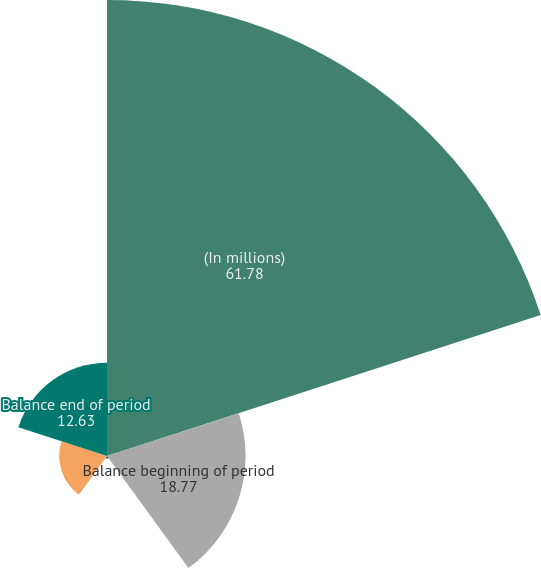Convert chart to OTSL. <chart><loc_0><loc_0><loc_500><loc_500><pie_chart><fcel>(In millions)<fcel>Balance beginning of period<fcel>Losses for which other-than-<fcel>Previously recognized losses<fcel>Balance end of period<nl><fcel>61.78%<fcel>18.77%<fcel>0.34%<fcel>6.48%<fcel>12.63%<nl></chart> 